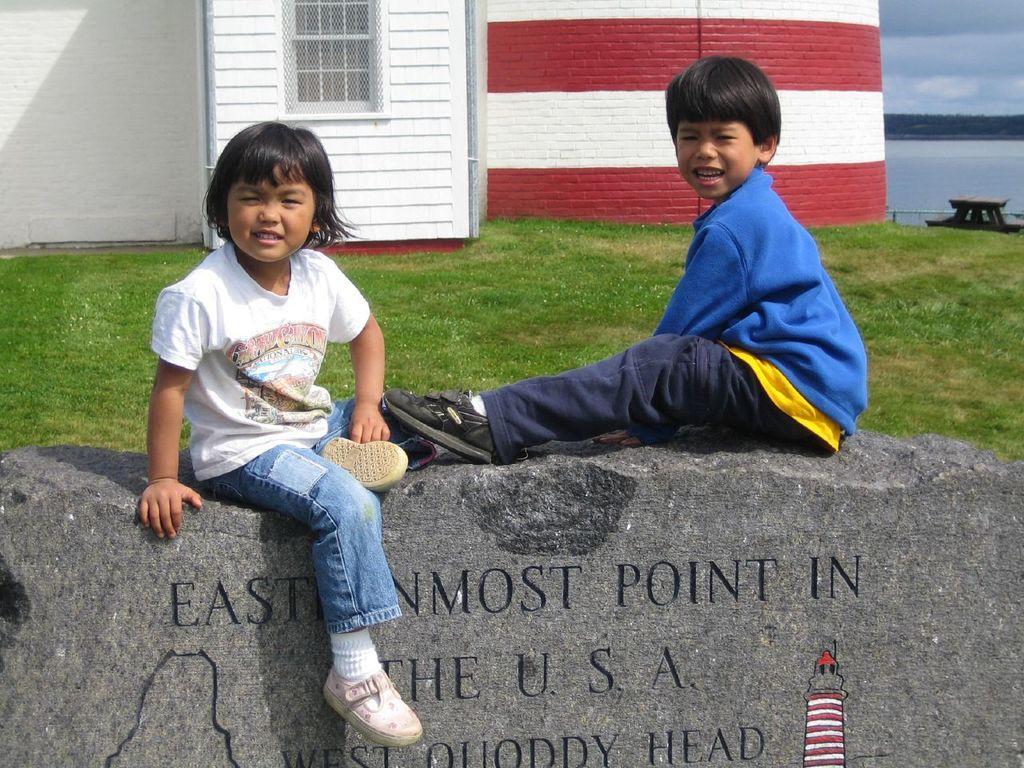Could you give a brief overview of what you see in this image? We can see a boy and a girl are sitting on a stone plate and there is text written on the stone and there is a tower design on it. In the background there is a grass on the ground,building,windows,poles,water,trees and clouds in the sky. 